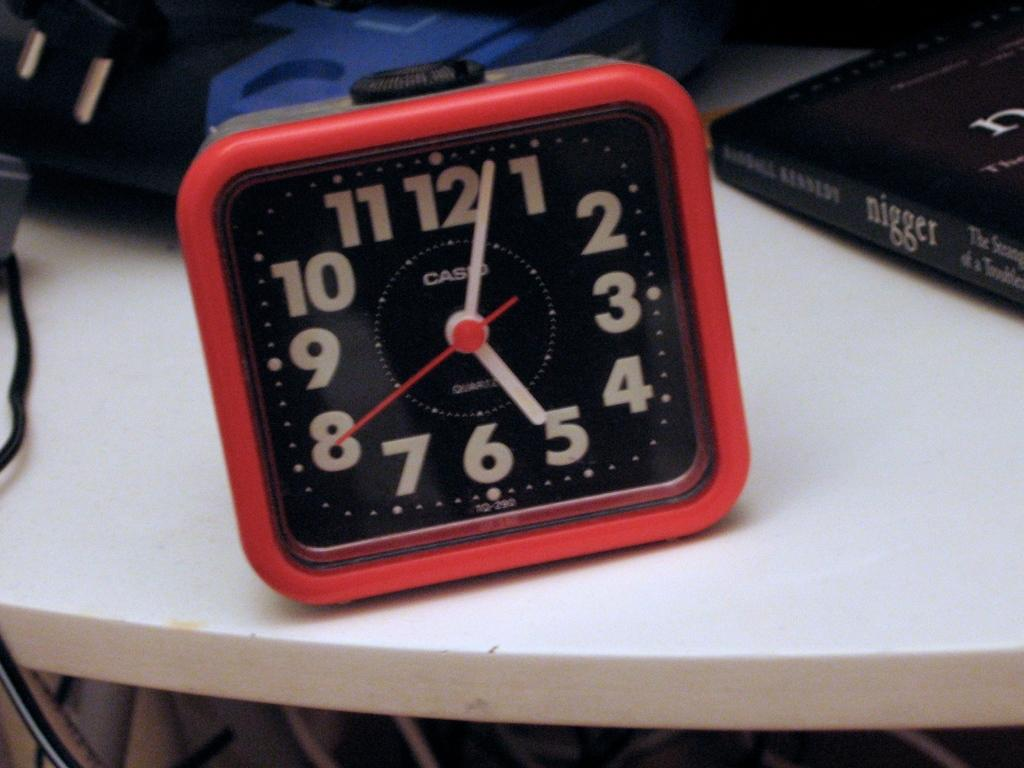<image>
Give a short and clear explanation of the subsequent image. A red Casio clock sits on a table next to an offensive titled book. 